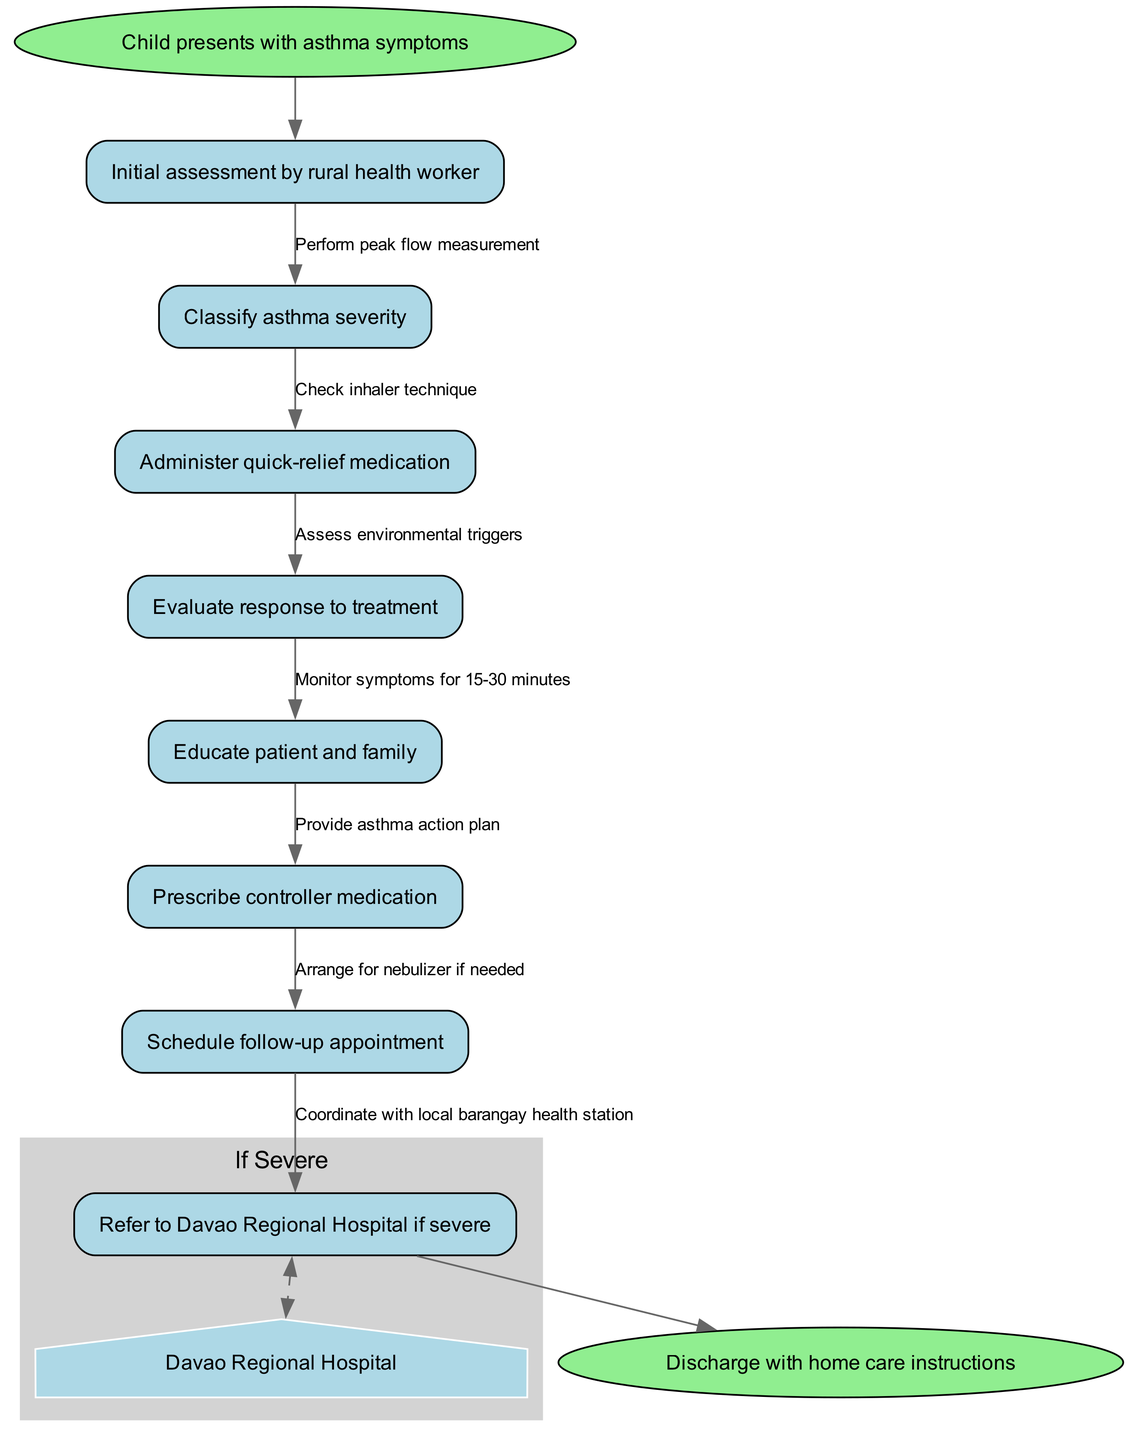What is the starting point of the clinical pathway? The starting point is indicated as "Child presents with asthma symptoms". This is shown as the first node in the diagram, which initiates the clinical pathway.
Answer: Child presents with asthma symptoms How many main nodes are there in the pathway? The main nodes are the individual steps in the pathway, which include the initial assessment, classification, treatment, education, and others listed. Counting them gives a total of 8 nodes.
Answer: 8 What medication is administered after classifying asthma severity? The node directly following "Classify asthma severity" indicates that "Administer quick-relief medication" is the next step. This is a key action taken to manage asthma symptoms.
Answer: Administer quick-relief medication What is the purpose of evaluating response to treatment? "Evaluate response to treatment" is meant to assess the effectiveness of the quick-relief medication administered. This step is crucial in determining if the subsequent actions are needed based on the child's response.
Answer: Assess effectiveness What does the pathway suggest if asthma is classified as severe? The diagram specifies to "Refer to Davao Regional Hospital if severe" if the initial assessment/management indicates a severe case. This establishes clear referral protocols for serious cases.
Answer: Refer to Davao Regional Hospital What is arranged if the response to treatment is inadequate? The pathway indicates that if the child's response to the quick-relief medication is not adequate, "Arrange for nebulizer if needed" is suggested. This step is crucial in escalating treatment as necessary.
Answer: Arrange for nebulizer What document is provided to the family for managing the child’s asthma? A "Provide asthma action plan" is mentioned as a key part of education for the patient and family during the clinical pathway. This document outlines how to manage asthma at home.
Answer: Provide asthma action plan What should be checked according to the pathway during the initial assessment? During the initial assessment, it's important to "Check inhaler technique." This step ensures that the patient knows how to properly use their inhaler, which is critical for effective treatment.
Answer: Check inhaler technique How long should symptoms be monitored after administering medication? The pathway states to "Monitor symptoms for 15-30 minutes." This is an important timeframe to observe the child's reaction to the treatment provided.
Answer: 15-30 minutes 